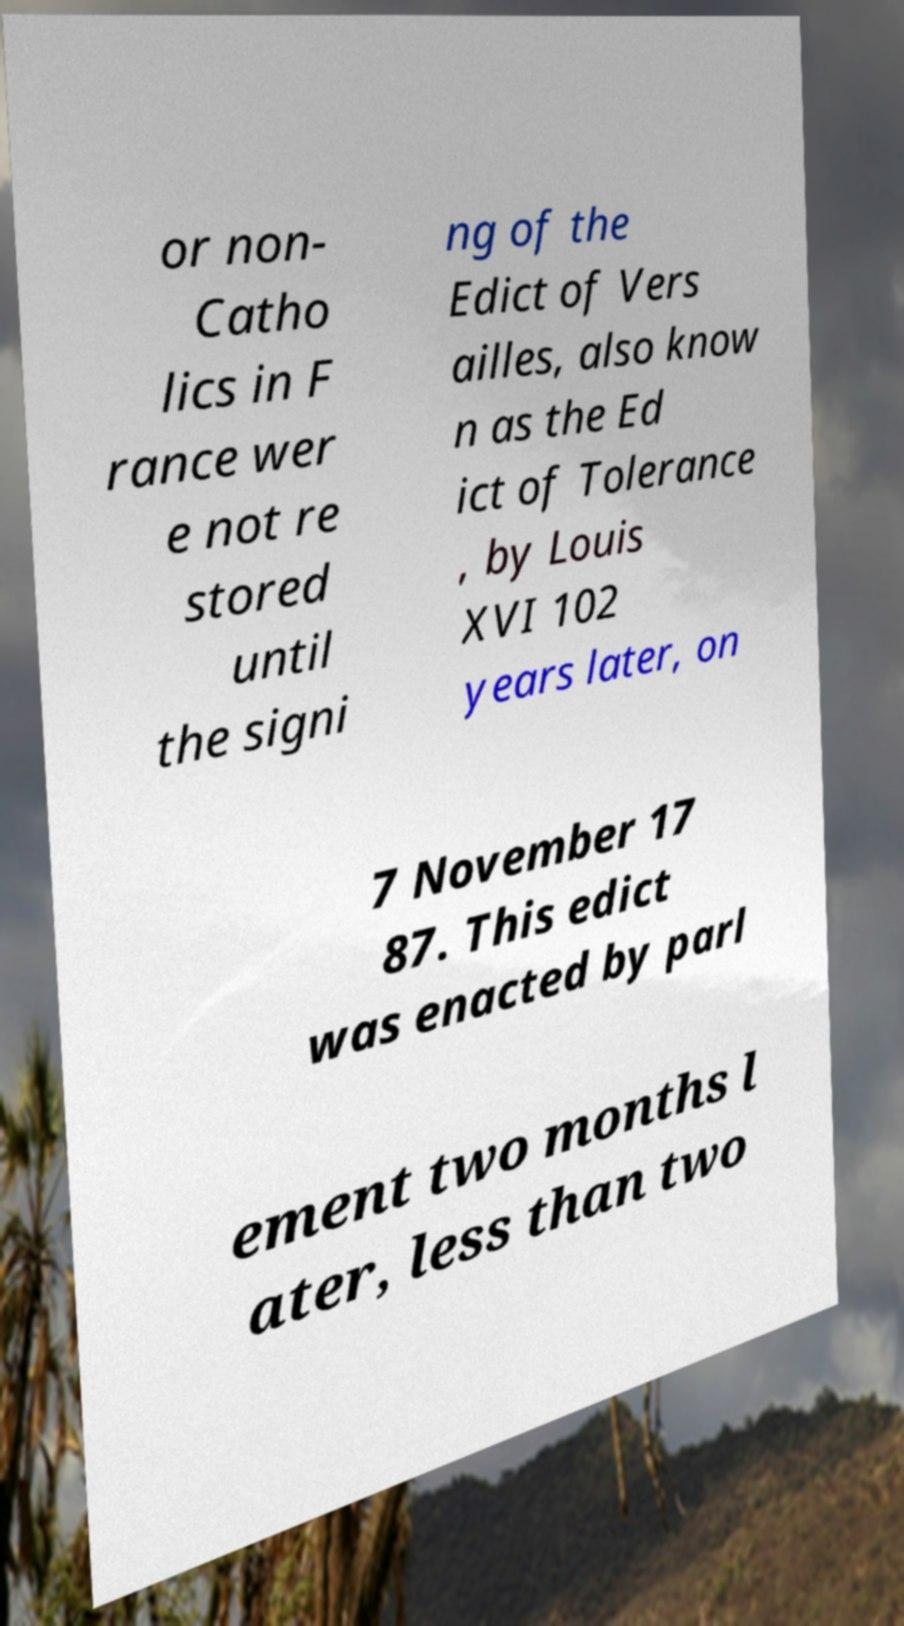For documentation purposes, I need the text within this image transcribed. Could you provide that? or non- Catho lics in F rance wer e not re stored until the signi ng of the Edict of Vers ailles, also know n as the Ed ict of Tolerance , by Louis XVI 102 years later, on 7 November 17 87. This edict was enacted by parl ement two months l ater, less than two 